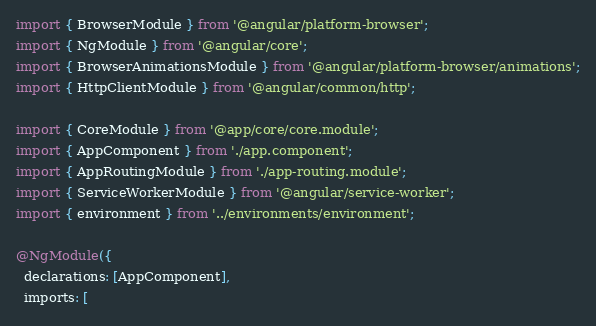Convert code to text. <code><loc_0><loc_0><loc_500><loc_500><_TypeScript_>import { BrowserModule } from '@angular/platform-browser';
import { NgModule } from '@angular/core';
import { BrowserAnimationsModule } from '@angular/platform-browser/animations';
import { HttpClientModule } from '@angular/common/http';

import { CoreModule } from '@app/core/core.module';
import { AppComponent } from './app.component';
import { AppRoutingModule } from './app-routing.module';
import { ServiceWorkerModule } from '@angular/service-worker';
import { environment } from '../environments/environment';

@NgModule({
  declarations: [AppComponent],
  imports: [</code> 